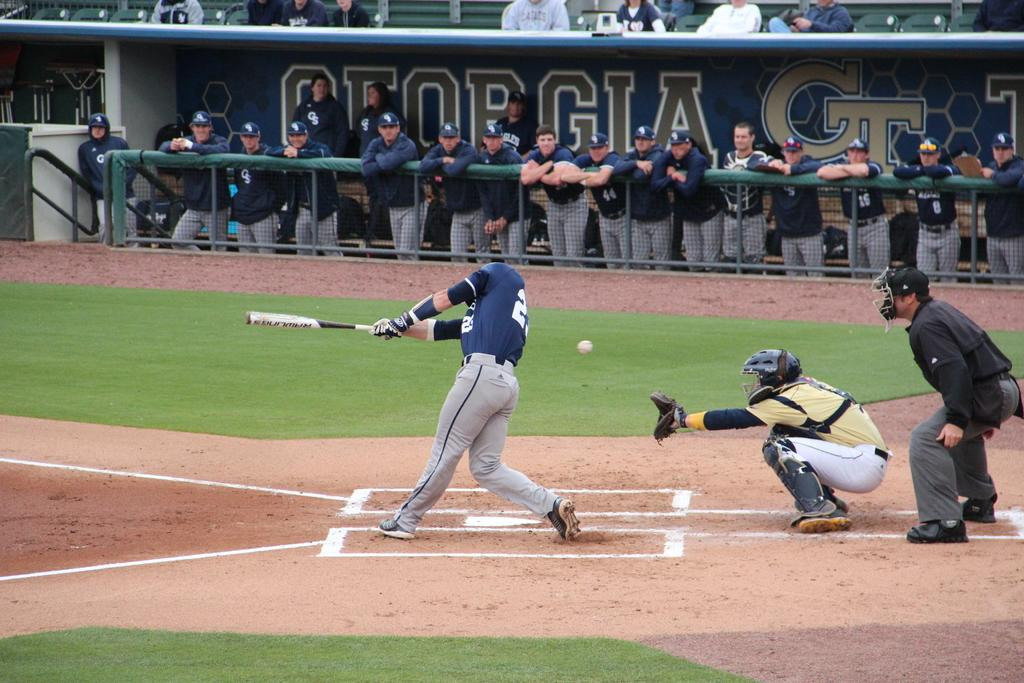<image>
Provide a brief description of the given image. Georgia tech baseball team is playing baseball on the outfield 